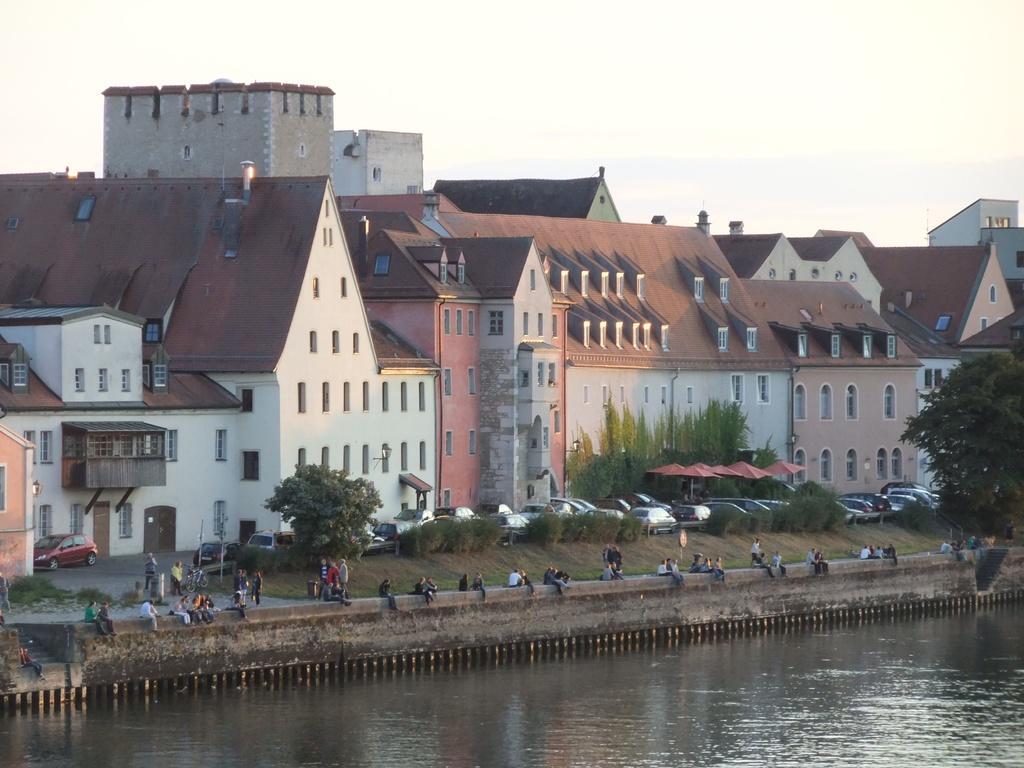Can you describe this image briefly? In this image I can see water, few trees, number of vehicles, number of buildings, number of windows and here I can see number of people. I can see few of them are standing and rest all are sitting. 